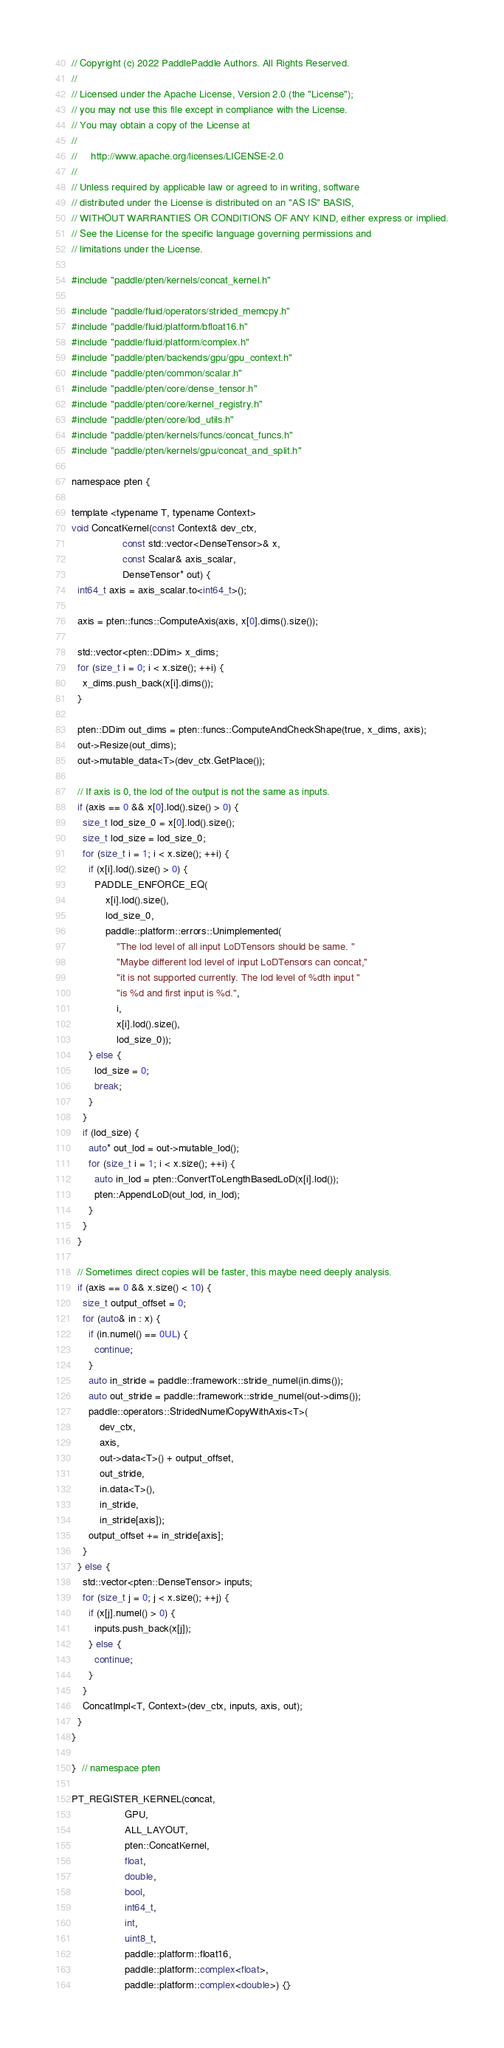<code> <loc_0><loc_0><loc_500><loc_500><_Cuda_>// Copyright (c) 2022 PaddlePaddle Authors. All Rights Reserved.
//
// Licensed under the Apache License, Version 2.0 (the "License");
// you may not use this file except in compliance with the License.
// You may obtain a copy of the License at
//
//     http://www.apache.org/licenses/LICENSE-2.0
//
// Unless required by applicable law or agreed to in writing, software
// distributed under the License is distributed on an "AS IS" BASIS,
// WITHOUT WARRANTIES OR CONDITIONS OF ANY KIND, either express or implied.
// See the License for the specific language governing permissions and
// limitations under the License.

#include "paddle/pten/kernels/concat_kernel.h"

#include "paddle/fluid/operators/strided_memcpy.h"
#include "paddle/fluid/platform/bfloat16.h"
#include "paddle/fluid/platform/complex.h"
#include "paddle/pten/backends/gpu/gpu_context.h"
#include "paddle/pten/common/scalar.h"
#include "paddle/pten/core/dense_tensor.h"
#include "paddle/pten/core/kernel_registry.h"
#include "paddle/pten/core/lod_utils.h"
#include "paddle/pten/kernels/funcs/concat_funcs.h"
#include "paddle/pten/kernels/gpu/concat_and_split.h"

namespace pten {

template <typename T, typename Context>
void ConcatKernel(const Context& dev_ctx,
                  const std::vector<DenseTensor>& x,
                  const Scalar& axis_scalar,
                  DenseTensor* out) {
  int64_t axis = axis_scalar.to<int64_t>();

  axis = pten::funcs::ComputeAxis(axis, x[0].dims().size());

  std::vector<pten::DDim> x_dims;
  for (size_t i = 0; i < x.size(); ++i) {
    x_dims.push_back(x[i].dims());
  }

  pten::DDim out_dims = pten::funcs::ComputeAndCheckShape(true, x_dims, axis);
  out->Resize(out_dims);
  out->mutable_data<T>(dev_ctx.GetPlace());

  // If axis is 0, the lod of the output is not the same as inputs.
  if (axis == 0 && x[0].lod().size() > 0) {
    size_t lod_size_0 = x[0].lod().size();
    size_t lod_size = lod_size_0;
    for (size_t i = 1; i < x.size(); ++i) {
      if (x[i].lod().size() > 0) {
        PADDLE_ENFORCE_EQ(
            x[i].lod().size(),
            lod_size_0,
            paddle::platform::errors::Unimplemented(
                "The lod level of all input LoDTensors should be same. "
                "Maybe different lod level of input LoDTensors can concat,"
                "it is not supported currently. The lod level of %dth input "
                "is %d and first input is %d.",
                i,
                x[i].lod().size(),
                lod_size_0));
      } else {
        lod_size = 0;
        break;
      }
    }
    if (lod_size) {
      auto* out_lod = out->mutable_lod();
      for (size_t i = 1; i < x.size(); ++i) {
        auto in_lod = pten::ConvertToLengthBasedLoD(x[i].lod());
        pten::AppendLoD(out_lod, in_lod);
      }
    }
  }

  // Sometimes direct copies will be faster, this maybe need deeply analysis.
  if (axis == 0 && x.size() < 10) {
    size_t output_offset = 0;
    for (auto& in : x) {
      if (in.numel() == 0UL) {
        continue;
      }
      auto in_stride = paddle::framework::stride_numel(in.dims());
      auto out_stride = paddle::framework::stride_numel(out->dims());
      paddle::operators::StridedNumelCopyWithAxis<T>(
          dev_ctx,
          axis,
          out->data<T>() + output_offset,
          out_stride,
          in.data<T>(),
          in_stride,
          in_stride[axis]);
      output_offset += in_stride[axis];
    }
  } else {
    std::vector<pten::DenseTensor> inputs;
    for (size_t j = 0; j < x.size(); ++j) {
      if (x[j].numel() > 0) {
        inputs.push_back(x[j]);
      } else {
        continue;
      }
    }
    ConcatImpl<T, Context>(dev_ctx, inputs, axis, out);
  }
}

}  // namespace pten

PT_REGISTER_KERNEL(concat,
                   GPU,
                   ALL_LAYOUT,
                   pten::ConcatKernel,
                   float,
                   double,
                   bool,
                   int64_t,
                   int,
                   uint8_t,
                   paddle::platform::float16,
                   paddle::platform::complex<float>,
                   paddle::platform::complex<double>) {}
</code> 